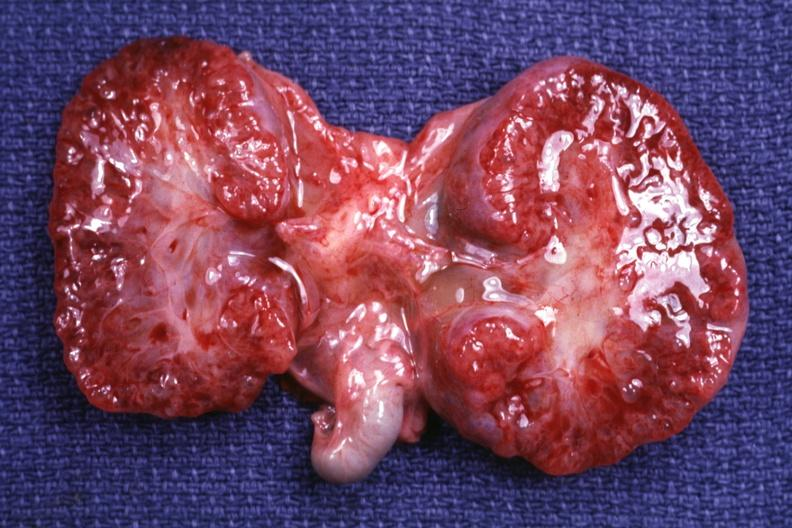what is present?
Answer the question using a single word or phrase. Polycystic disease infant 